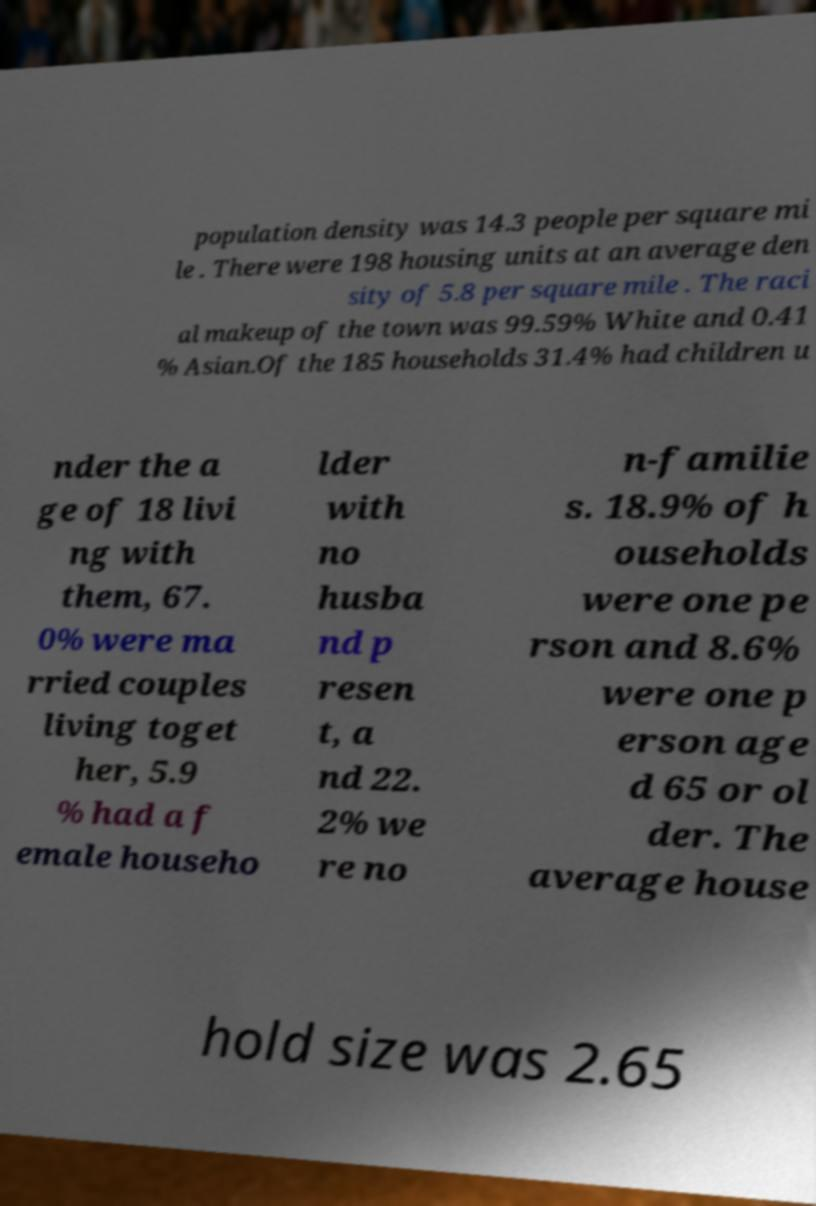Can you accurately transcribe the text from the provided image for me? population density was 14.3 people per square mi le . There were 198 housing units at an average den sity of 5.8 per square mile . The raci al makeup of the town was 99.59% White and 0.41 % Asian.Of the 185 households 31.4% had children u nder the a ge of 18 livi ng with them, 67. 0% were ma rried couples living toget her, 5.9 % had a f emale househo lder with no husba nd p resen t, a nd 22. 2% we re no n-familie s. 18.9% of h ouseholds were one pe rson and 8.6% were one p erson age d 65 or ol der. The average house hold size was 2.65 